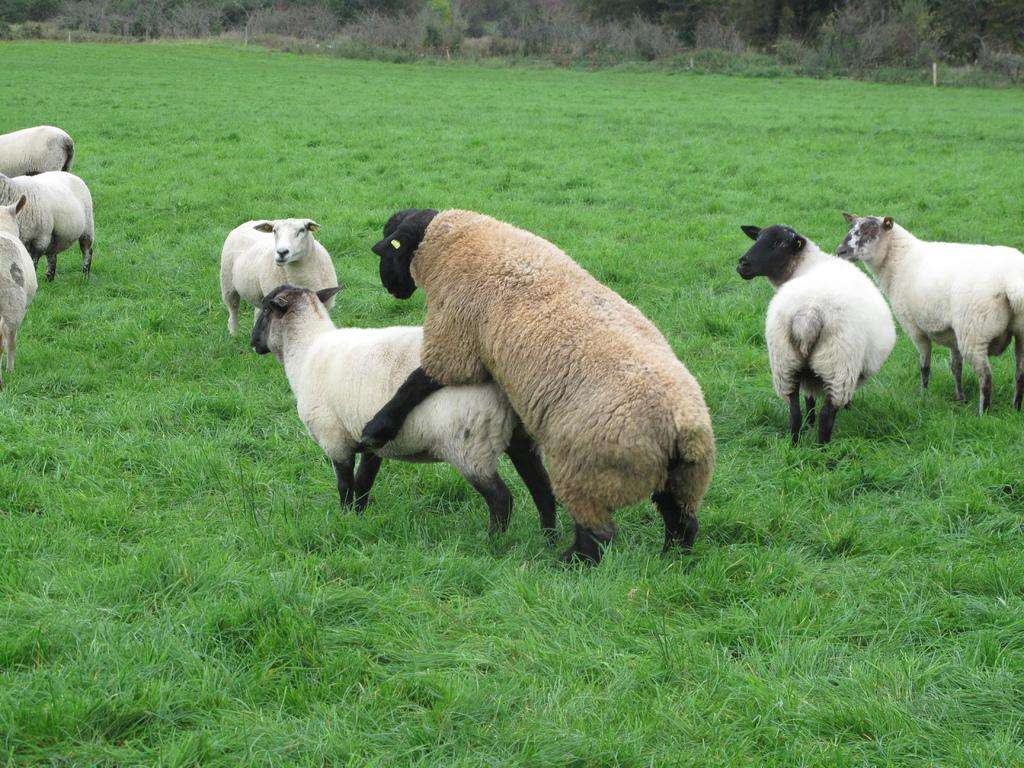What type of animals can be seen in the image? There are many goats in the image. What is the color of the grass at the bottom of the image? Green grass is visible at the bottom of the image. What type of vegetation is present at the top of the image? Trees are present at the top of the image. What else can be seen in the image besides the goats and vegetation? Plants are visible in the image. What type of question is being asked in the image? There is no question present in the image; it features goats, grass, trees, and plants. Can you see a pencil being used to write a note in the image? There is no pencil or note present in the image. 